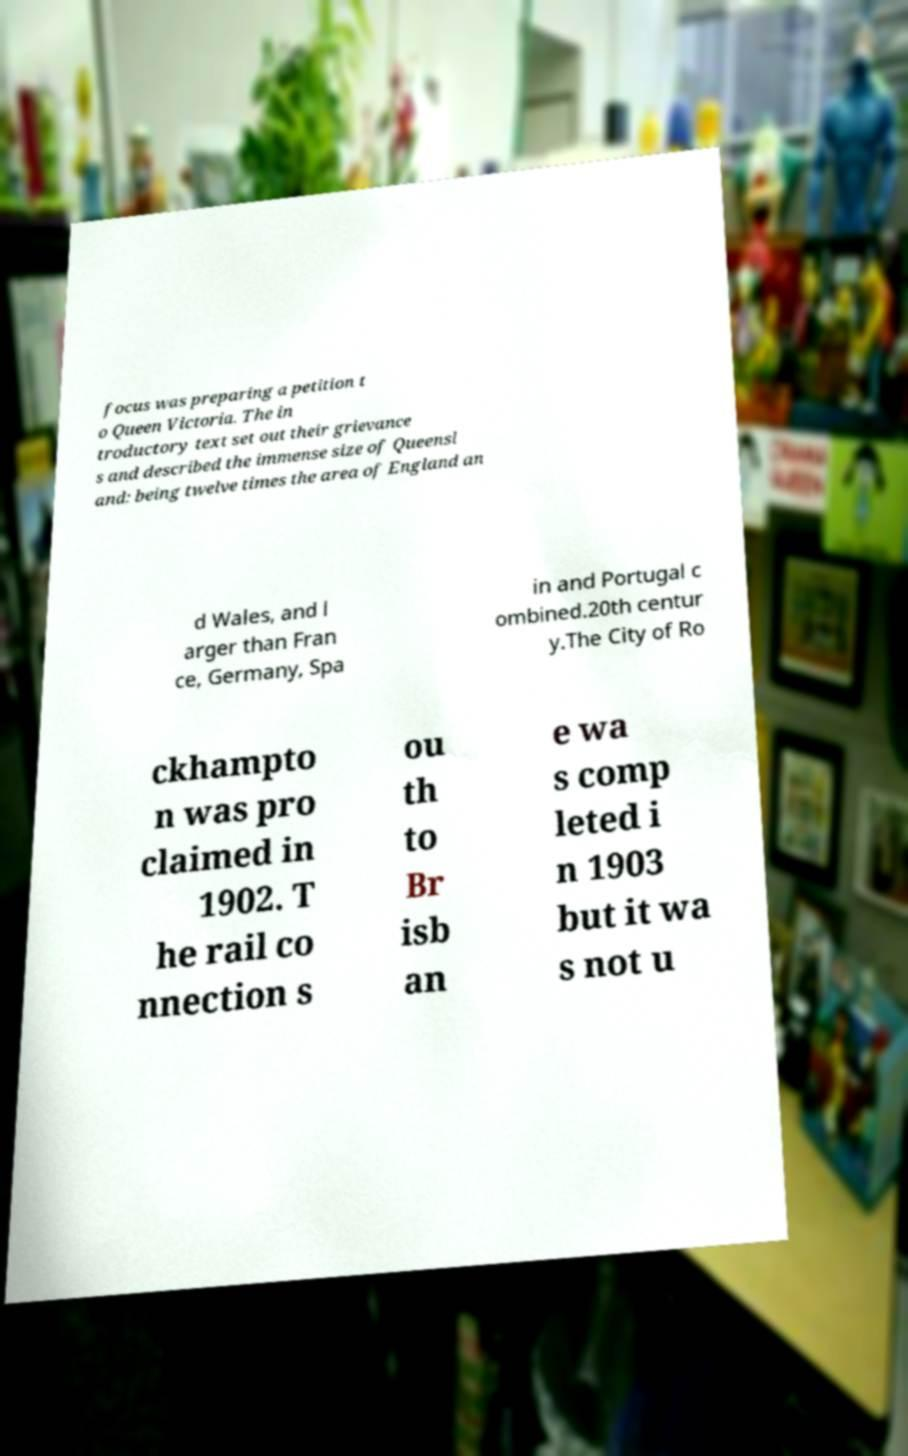What messages or text are displayed in this image? I need them in a readable, typed format. focus was preparing a petition t o Queen Victoria. The in troductory text set out their grievance s and described the immense size of Queensl and: being twelve times the area of England an d Wales, and l arger than Fran ce, Germany, Spa in and Portugal c ombined.20th centur y.The City of Ro ckhampto n was pro claimed in 1902. T he rail co nnection s ou th to Br isb an e wa s comp leted i n 1903 but it wa s not u 